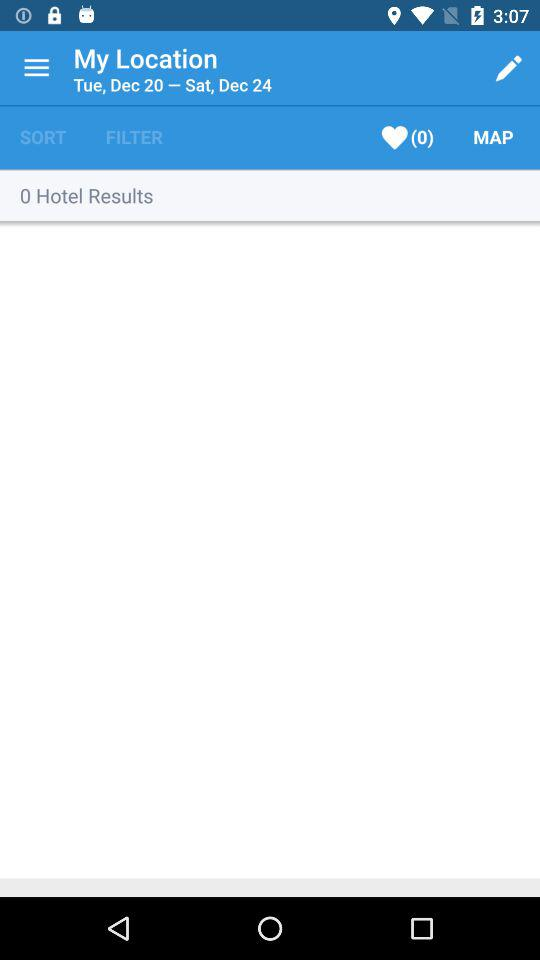Are there any results for the hotels? There are 0 results for the hotels. 